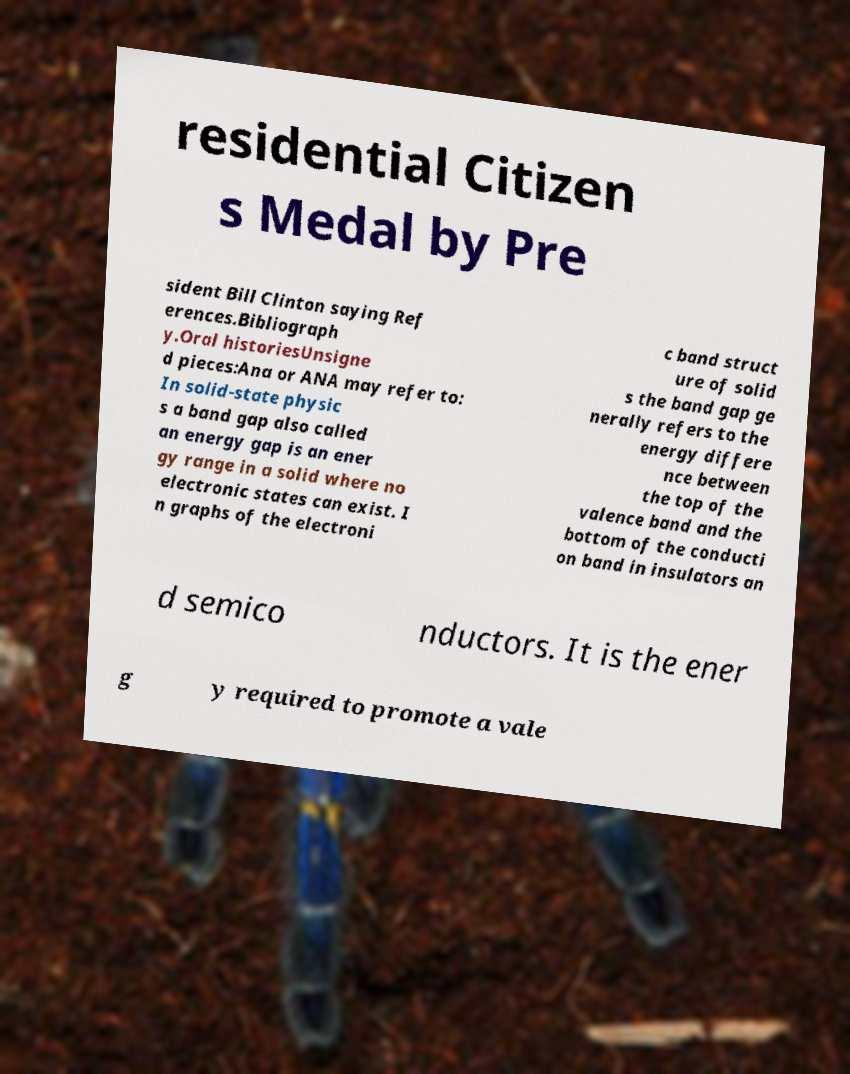Can you read and provide the text displayed in the image?This photo seems to have some interesting text. Can you extract and type it out for me? residential Citizen s Medal by Pre sident Bill Clinton saying Ref erences.Bibliograph y.Oral historiesUnsigne d pieces:Ana or ANA may refer to: In solid-state physic s a band gap also called an energy gap is an ener gy range in a solid where no electronic states can exist. I n graphs of the electroni c band struct ure of solid s the band gap ge nerally refers to the energy differe nce between the top of the valence band and the bottom of the conducti on band in insulators an d semico nductors. It is the ener g y required to promote a vale 